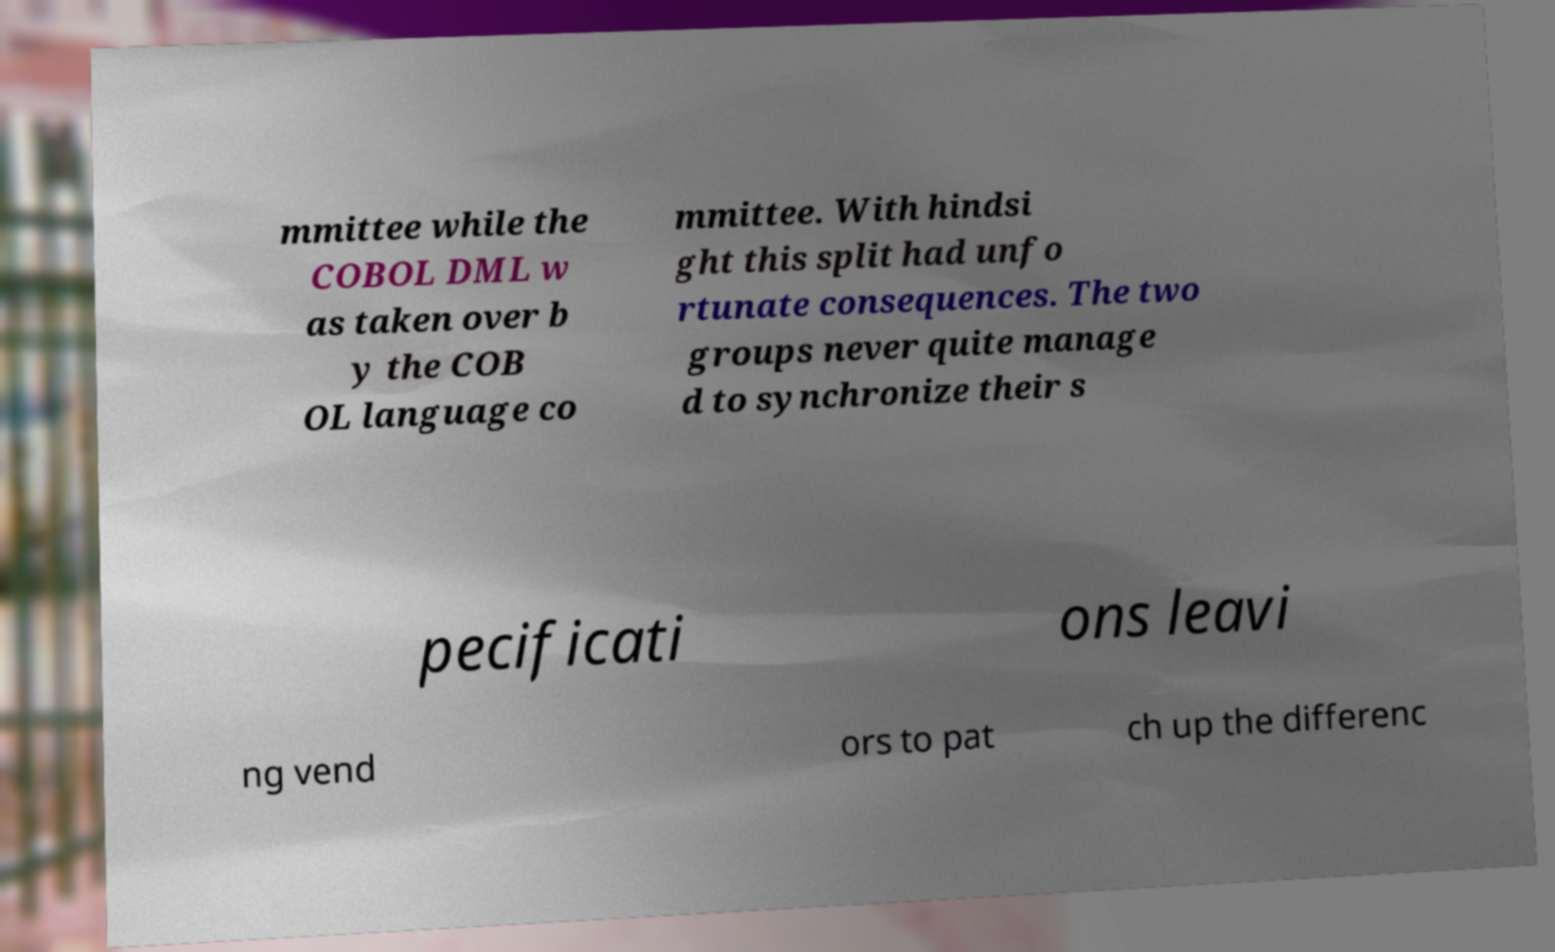Could you assist in decoding the text presented in this image and type it out clearly? mmittee while the COBOL DML w as taken over b y the COB OL language co mmittee. With hindsi ght this split had unfo rtunate consequences. The two groups never quite manage d to synchronize their s pecificati ons leavi ng vend ors to pat ch up the differenc 